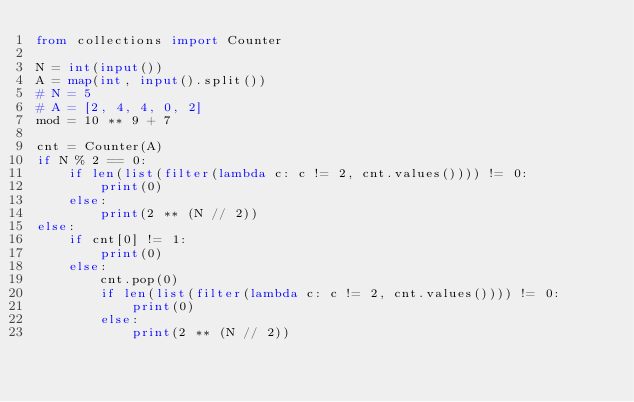Convert code to text. <code><loc_0><loc_0><loc_500><loc_500><_Python_>from collections import Counter

N = int(input())
A = map(int, input().split())
# N = 5
# A = [2, 4, 4, 0, 2]
mod = 10 ** 9 + 7

cnt = Counter(A)
if N % 2 == 0:
    if len(list(filter(lambda c: c != 2, cnt.values()))) != 0:
        print(0)
    else:
        print(2 ** (N // 2))
else:
    if cnt[0] != 1:
        print(0)
    else:
        cnt.pop(0)
        if len(list(filter(lambda c: c != 2, cnt.values()))) != 0:
            print(0)
        else:
            print(2 ** (N // 2))
</code> 